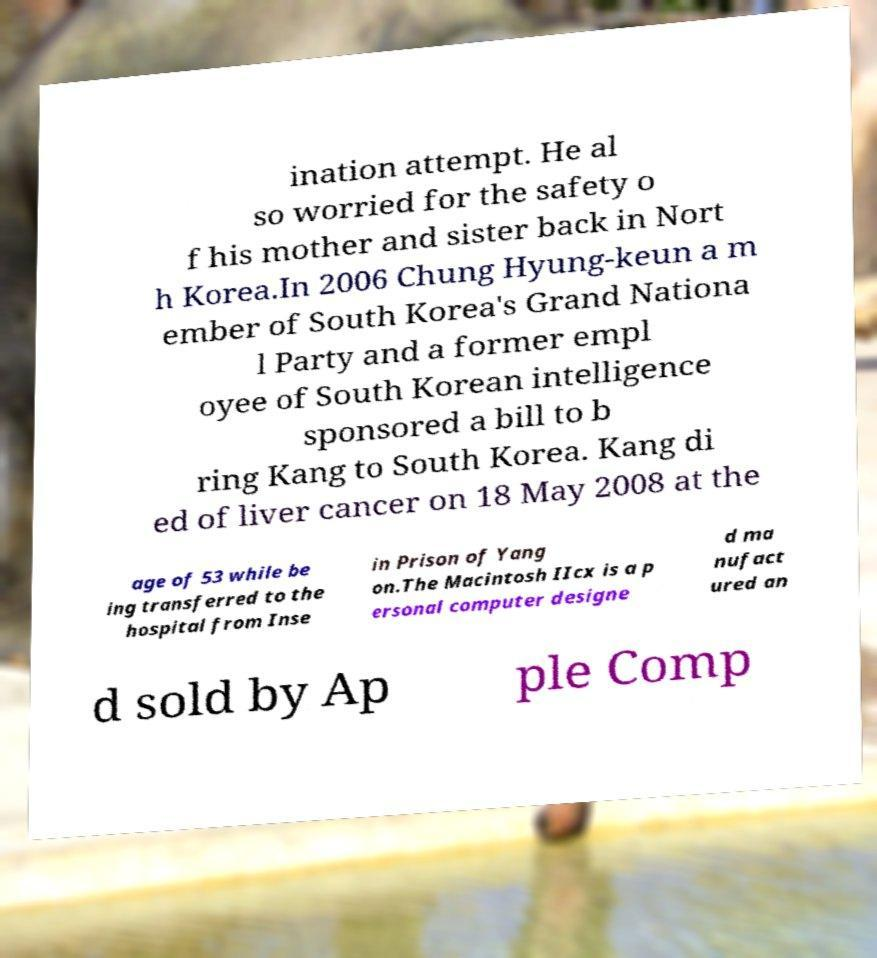Can you accurately transcribe the text from the provided image for me? ination attempt. He al so worried for the safety o f his mother and sister back in Nort h Korea.In 2006 Chung Hyung-keun a m ember of South Korea's Grand Nationa l Party and a former empl oyee of South Korean intelligence sponsored a bill to b ring Kang to South Korea. Kang di ed of liver cancer on 18 May 2008 at the age of 53 while be ing transferred to the hospital from Inse in Prison of Yang on.The Macintosh IIcx is a p ersonal computer designe d ma nufact ured an d sold by Ap ple Comp 